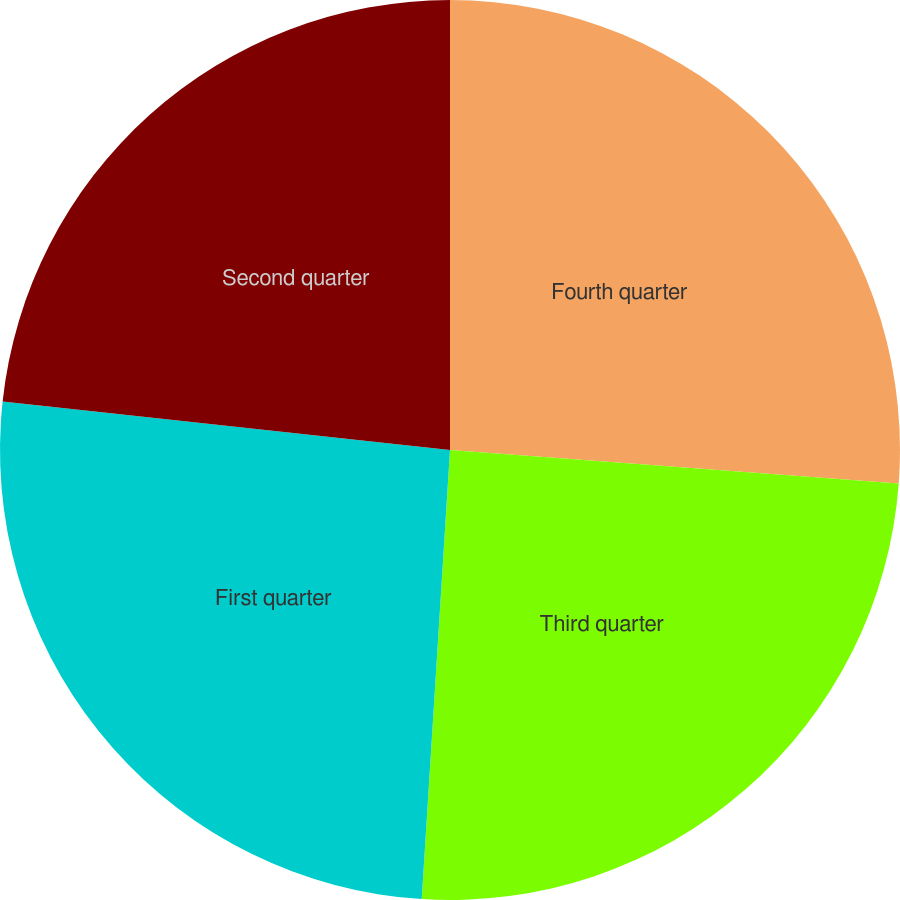Convert chart. <chart><loc_0><loc_0><loc_500><loc_500><pie_chart><fcel>Fourth quarter<fcel>Third quarter<fcel>First quarter<fcel>Second quarter<nl><fcel>26.19%<fcel>24.81%<fcel>25.72%<fcel>23.28%<nl></chart> 